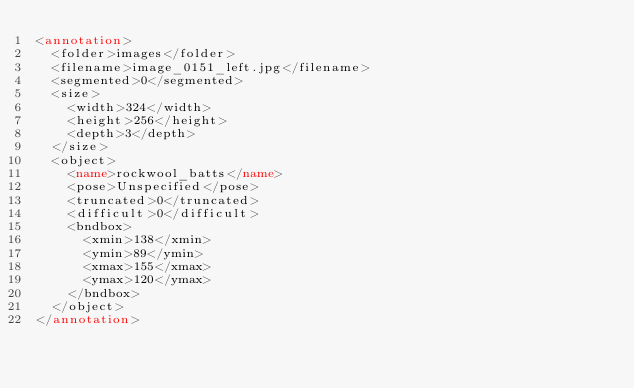<code> <loc_0><loc_0><loc_500><loc_500><_XML_><annotation>
  <folder>images</folder>
  <filename>image_0151_left.jpg</filename>
  <segmented>0</segmented>
  <size>
    <width>324</width>
    <height>256</height>
    <depth>3</depth>
  </size>
  <object>
    <name>rockwool_batts</name>
    <pose>Unspecified</pose>
    <truncated>0</truncated>
    <difficult>0</difficult>
    <bndbox>
      <xmin>138</xmin>
      <ymin>89</ymin>
      <xmax>155</xmax>
      <ymax>120</ymax>
    </bndbox>
  </object>
</annotation></code> 